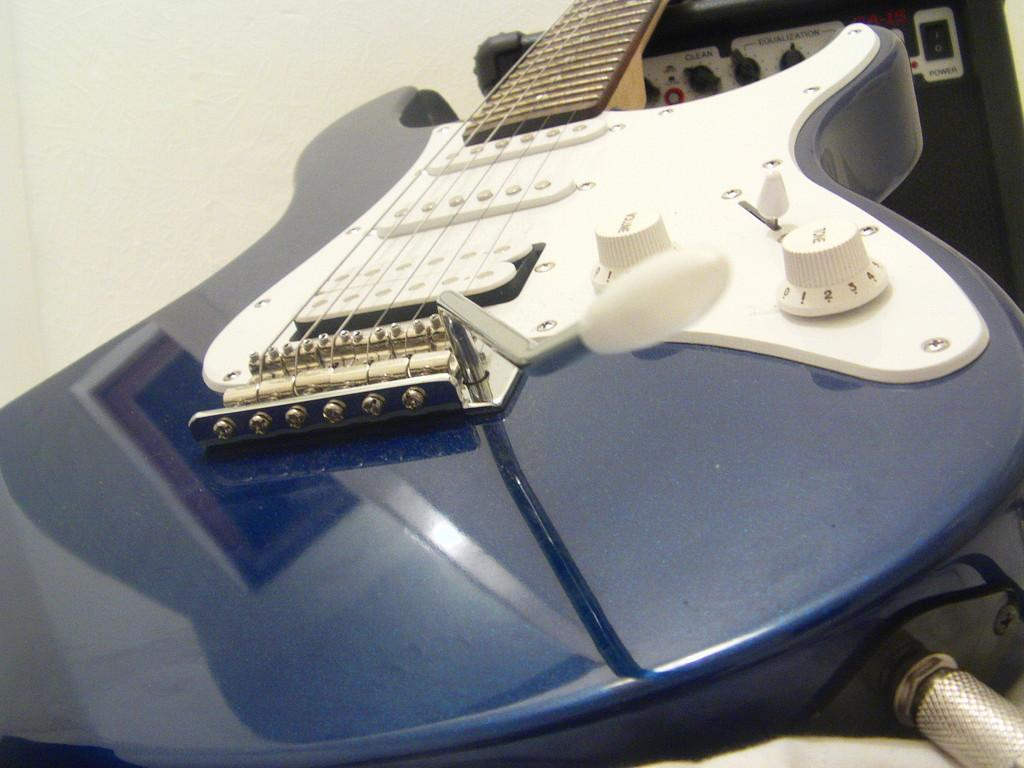What type of musical instrument is in the picture? There is a blue guitar in the picture. What color is the guitar? The guitar is blue. What can be seen in the background of the picture? There is a white wall in the background of the picture. What type of wood is used to make the shelf in the picture? There is no shelf present in the picture; it only features a blue guitar and a white wall in the background. 